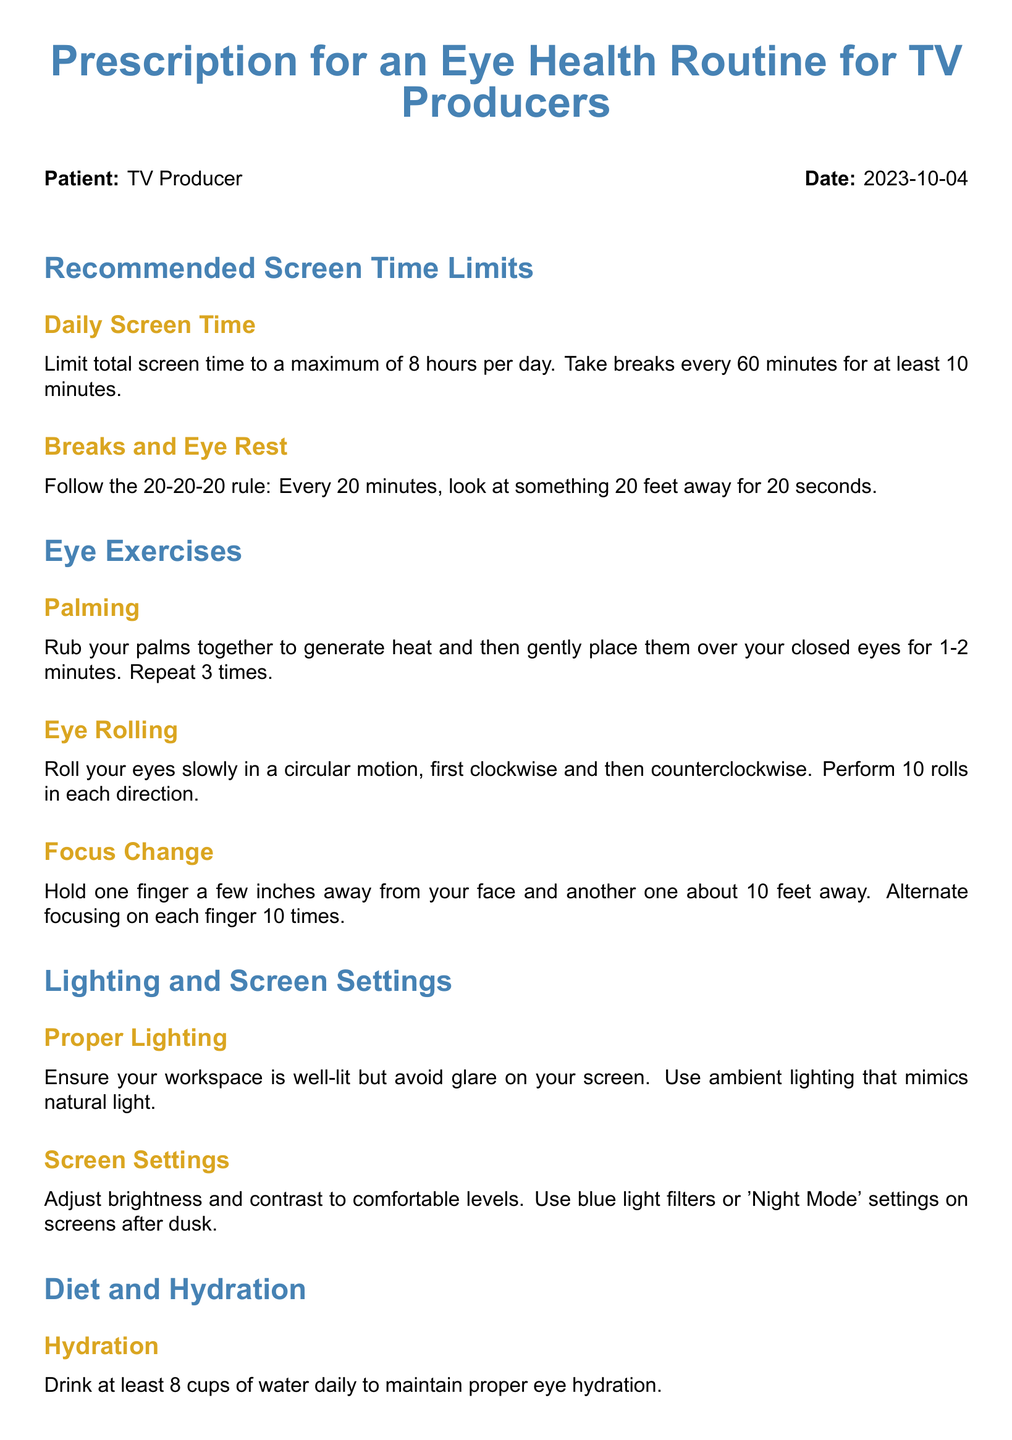What is the maximum daily screen time recommended? The document specifies limiting total screen time to a maximum of 8 hours per day.
Answer: 8 hours What is the 20-20-20 rule? The rule requires looking at something 20 feet away for 20 seconds every 20 minutes.
Answer: Look at something 20 feet away for 20 seconds How many cups of water should be consumed daily? The document advises drinking at least 8 cups of water daily for eye hydration.
Answer: 8 cups How often should one schedule a comprehensive eye exam? The recommendation is to schedule a comprehensive eye exam at least once annually.
Answer: At least once annually What are two nutrients mentioned for eye health? The document lists vitamins A, C, E, omega-3 fatty acids, and zinc as important nutrients.
Answer: Vitamins A and C How long should palming be repeated? The instruction states to repeat palming 3 times for 1-2 minutes each time.
Answer: 3 times What type of lighting is advised for the workspace? The document suggests ensuring the workspace is well-lit but avoiding glare on the screen.
Answer: Well-lit What should be adjusted on screens after dusk? The document recommends using blue light filters or 'Night Mode' settings on screens.
Answer: Blue light filters Who is the optometrist mentioned in the document? The document states Dr. Rebecca Harper is the optometrist.
Answer: Dr. Rebecca Harper 